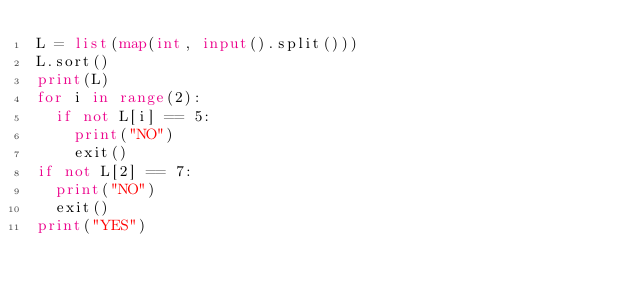<code> <loc_0><loc_0><loc_500><loc_500><_Python_>L = list(map(int, input().split()))
L.sort()
print(L)
for i in range(2):
  if not L[i] == 5:
    print("NO")
    exit()
if not L[2] == 7:
  print("NO")
  exit()
print("YES")</code> 